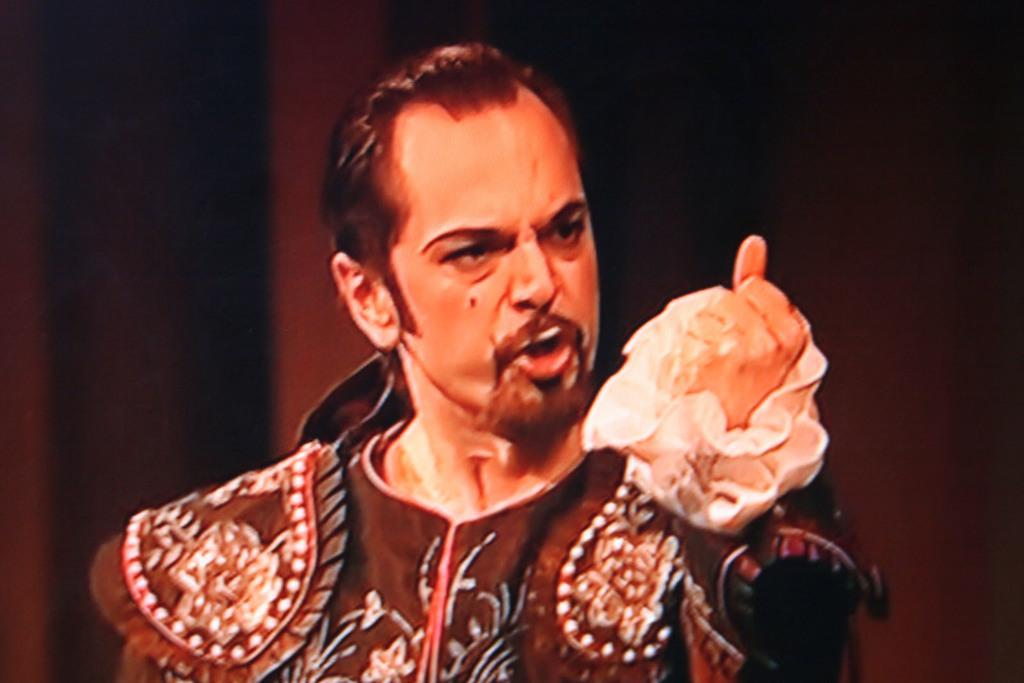What is the main subject of the image? The main subject of the image is a man. What is the man doing in the image? The man is performing an action. Can you describe the background of the image? The background of the image is dark. What type of wave can be seen in the image? There is no wave present in the image; it features a man performing an action against a dark background. 